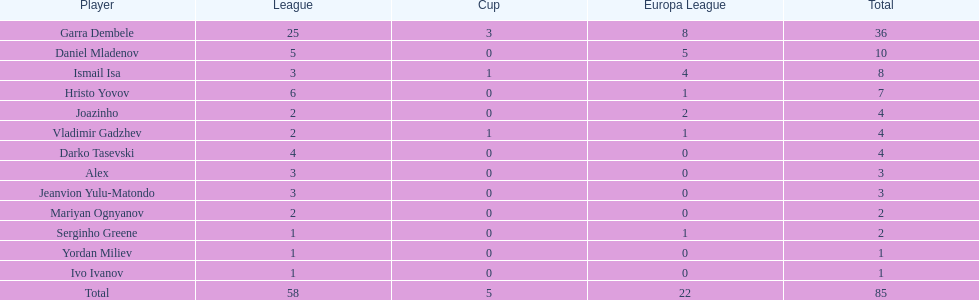Which player has the most goals to their name? Garra Dembele. 